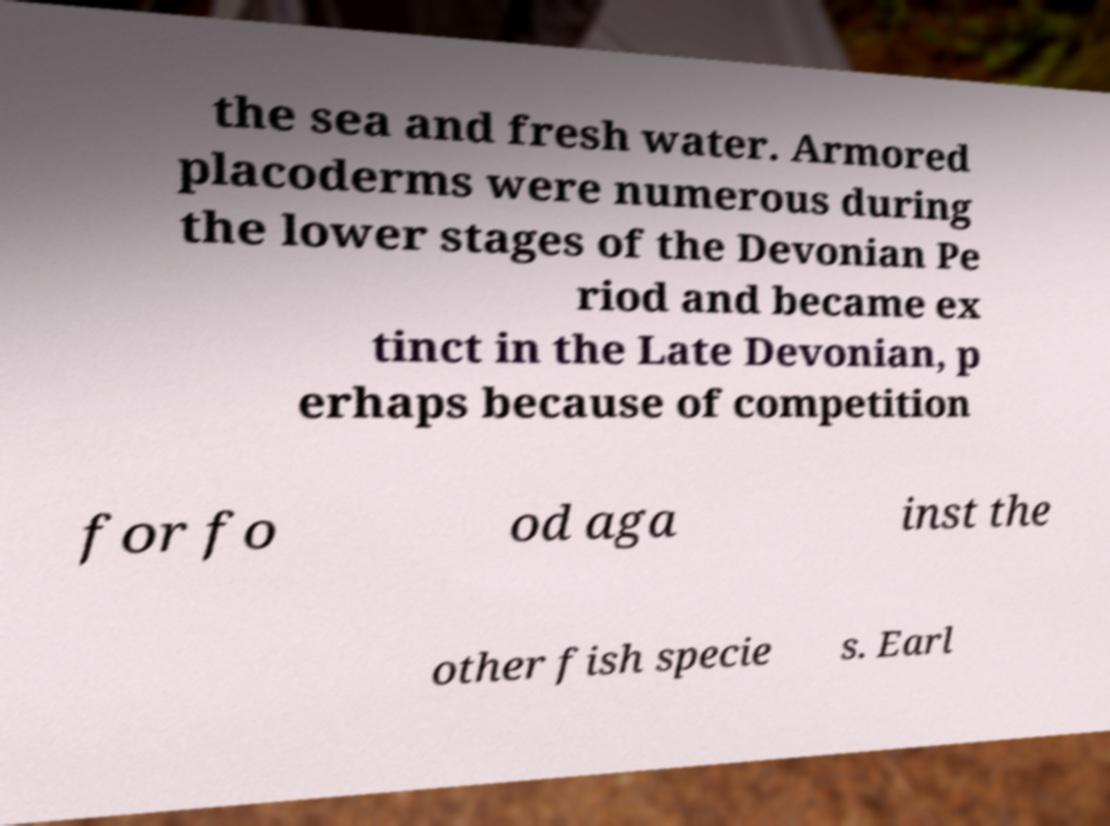Can you read and provide the text displayed in the image?This photo seems to have some interesting text. Can you extract and type it out for me? the sea and fresh water. Armored placoderms were numerous during the lower stages of the Devonian Pe riod and became ex tinct in the Late Devonian, p erhaps because of competition for fo od aga inst the other fish specie s. Earl 